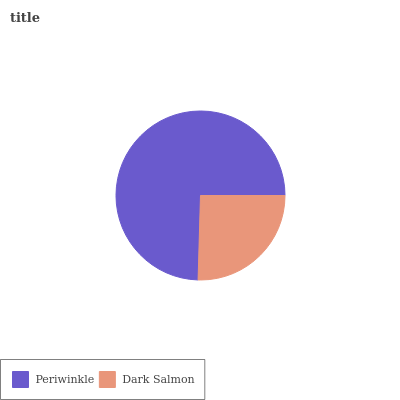Is Dark Salmon the minimum?
Answer yes or no. Yes. Is Periwinkle the maximum?
Answer yes or no. Yes. Is Dark Salmon the maximum?
Answer yes or no. No. Is Periwinkle greater than Dark Salmon?
Answer yes or no. Yes. Is Dark Salmon less than Periwinkle?
Answer yes or no. Yes. Is Dark Salmon greater than Periwinkle?
Answer yes or no. No. Is Periwinkle less than Dark Salmon?
Answer yes or no. No. Is Periwinkle the high median?
Answer yes or no. Yes. Is Dark Salmon the low median?
Answer yes or no. Yes. Is Dark Salmon the high median?
Answer yes or no. No. Is Periwinkle the low median?
Answer yes or no. No. 